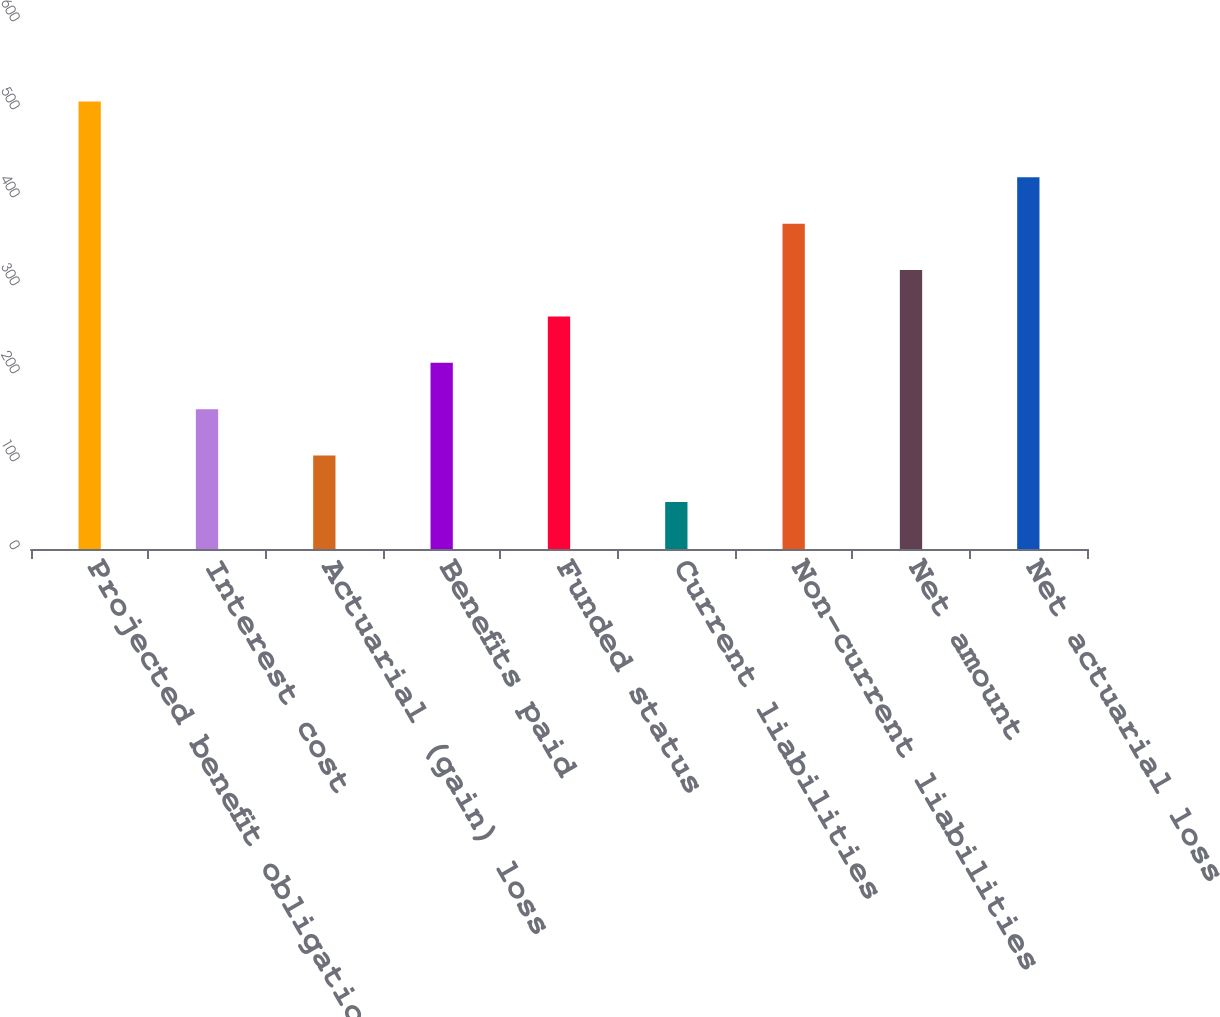<chart> <loc_0><loc_0><loc_500><loc_500><bar_chart><fcel>Projected benefit obligation<fcel>Interest cost<fcel>Actuarial (gain) loss<fcel>Benefits paid<fcel>Funded status<fcel>Current liabilities<fcel>Non-current liabilities<fcel>Net amount<fcel>Net actuarial loss<nl><fcel>508.5<fcel>158.83<fcel>106.12<fcel>211.54<fcel>264.25<fcel>53.41<fcel>369.67<fcel>316.96<fcel>422.38<nl></chart> 